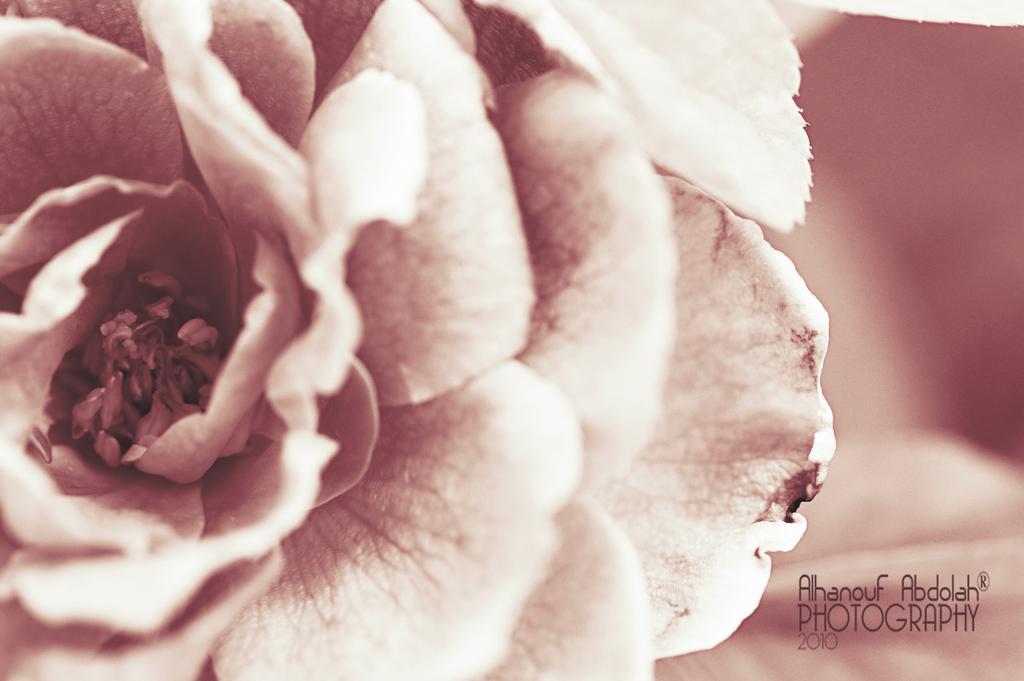Can you describe this image briefly? In this image I can see the flower in peach and cream color and I can see something written on the image. 